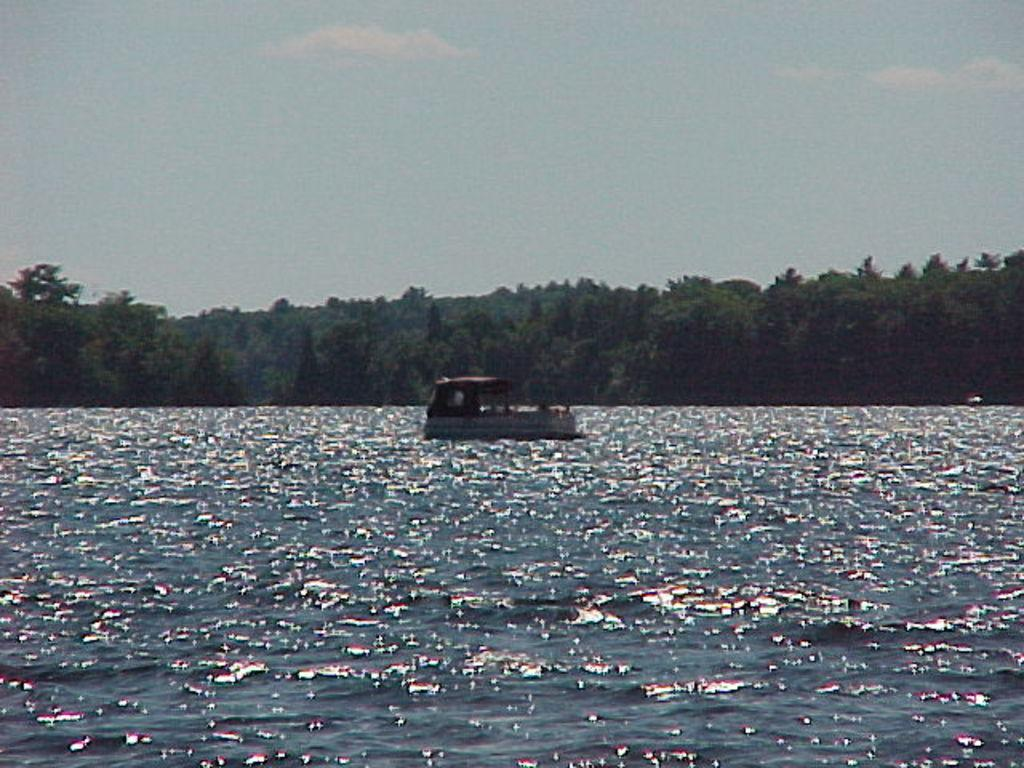What is the main subject of the image? The main subject of the image is a boat. Where is the boat located? The boat is in a large water body. What can be seen behind the boat? There is a group of trees visible on the backside of the boat. What is visible in the sky in the image? The sky is visible in the image. How would you describe the weather based on the sky in the image? The sky appears cloudy in the image. What type of paste is being used to fix the engine of the boat in the image? There is no mention of an engine or any paste in the image; it simply shows a boat in a water body with trees in the background and a cloudy sky. 